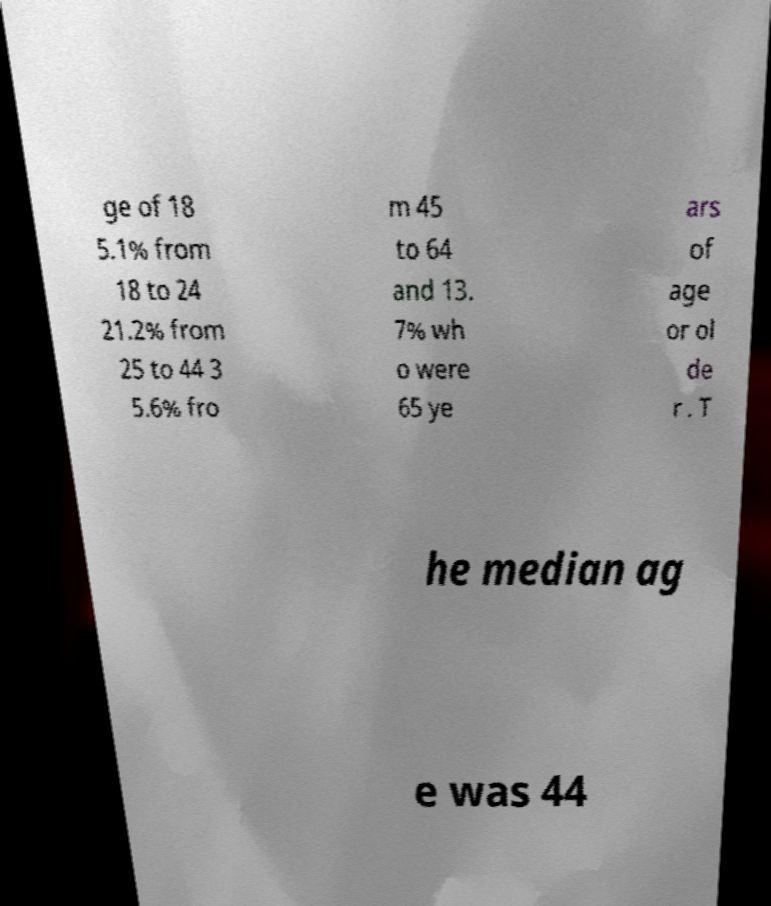Can you read and provide the text displayed in the image?This photo seems to have some interesting text. Can you extract and type it out for me? ge of 18 5.1% from 18 to 24 21.2% from 25 to 44 3 5.6% fro m 45 to 64 and 13. 7% wh o were 65 ye ars of age or ol de r . T he median ag e was 44 